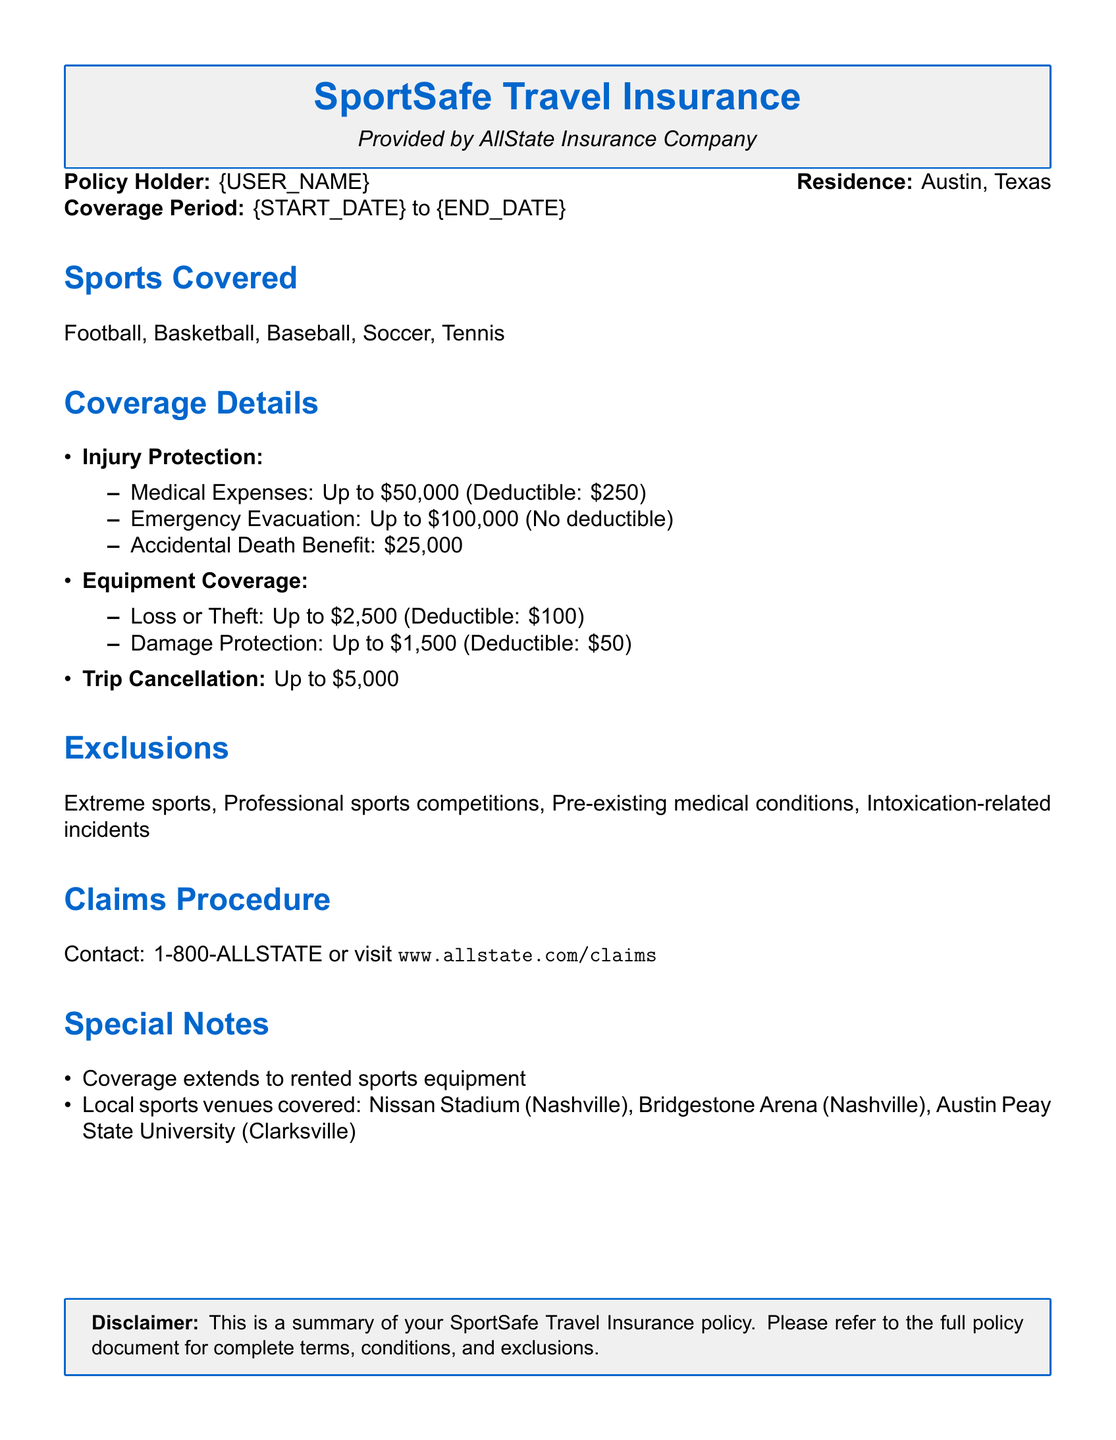What is the maximum medical expense coverage? The document states that medical expenses are covered up to $50,000.
Answer: $50,000 What is the deductible for equipment loss due to theft? The document specifies that the deductible for loss or theft of equipment is $100.
Answer: $100 What sports are covered under this policy? The policy lists the covered sports as football, basketball, baseball, soccer, and tennis.
Answer: Football, Basketball, Baseball, Soccer, Tennis What is the accidental death benefit amount? The document mentions that the accidental death benefit is $25,000.
Answer: $25,000 Are extreme sports covered under this insurance policy? The document clearly states that extreme sports are excluded from coverage.
Answer: No What is the limit for damage protection of equipment? The document indicates that damage protection is provided for up to $1,500.
Answer: $1,500 Which venues are specifically covered by this insurance? According to the document, local sports venues covered include Nissan Stadium, Bridgestone Arena, and Austin Peay State University.
Answer: Nissan Stadium, Bridgestone Arena, Austin Peay State University What is the maximum amount for trip cancellation coverage? The policy specifies that trip cancellation coverage is up to $5,000.
Answer: $5,000 